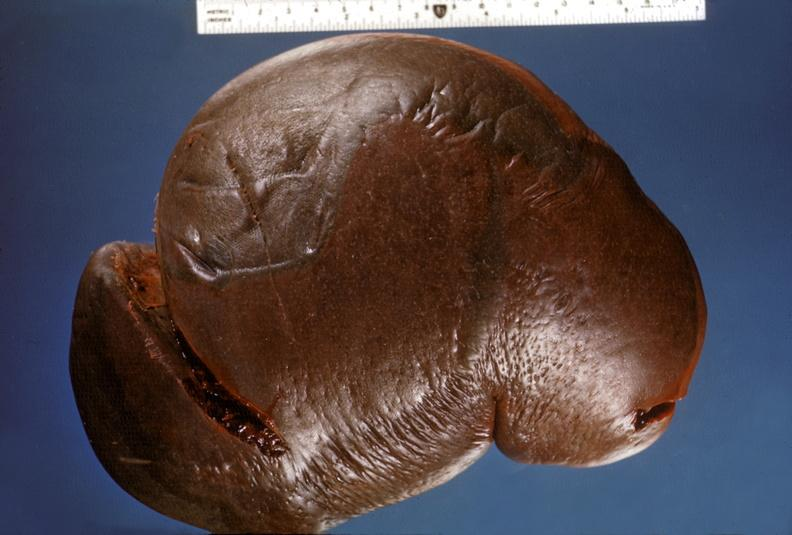what does this image show?
Answer the question using a single word or phrase. Spleen 